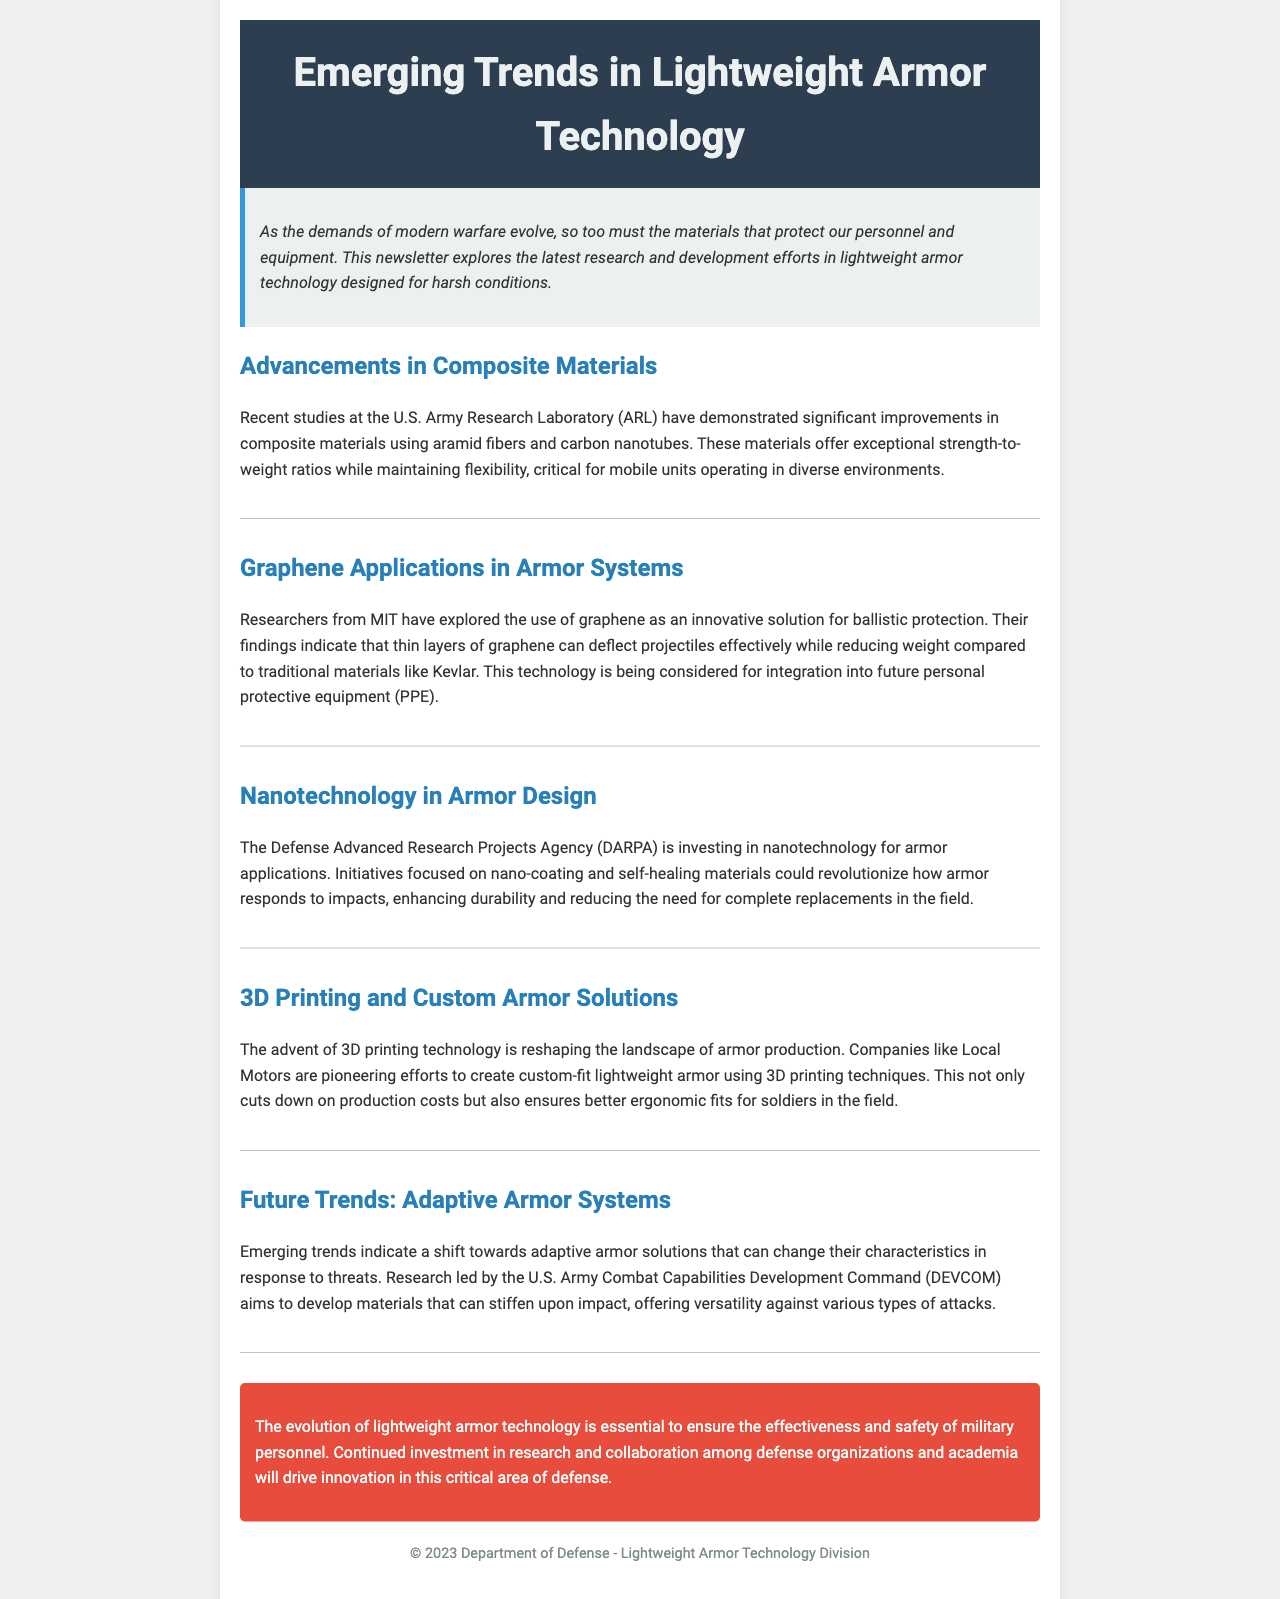What are the key materials demonstrated by ARL? The key materials demonstrated by the U.S. Army Research Laboratory (ARL) are aramid fibers and carbon nanotubes.
Answer: aramid fibers, carbon nanotubes Who led the research on graphene applications? The research on graphene applications was led by researchers from MIT.
Answer: MIT What is the focus of DARPA's investments in armor applications? DARPA is focusing on nanotechnology for armor applications, specifically on nano-coating and self-healing materials.
Answer: nanotechnology, nano-coating, self-healing materials What production technology is reshaping armor manufacturing? The advent of 3D printing technology is reshaping the landscape of armor production.
Answer: 3D printing What is a future trend mentioned regarding armor systems? A future trend mentioned is the development of adaptive armor solutions that can change characteristics in response to threats.
Answer: adaptive armor solutions What is a significant benefit of using graphene compared to traditional materials? The significant benefit of graphene is that it can deflect projectiles while reducing weight compared to traditional materials like Kevlar.
Answer: reducing weight What organization is associated with efforts to create custom-fit lightweight armor? The organization associated with creating custom-fit lightweight armor is Local Motors.
Answer: Local Motors What is the conclusion about the evolution of lightweight armor technology? The conclusion states that the evolution of lightweight armor technology is essential for military personnel's effectiveness and safety.
Answer: essential for effectiveness and safety 